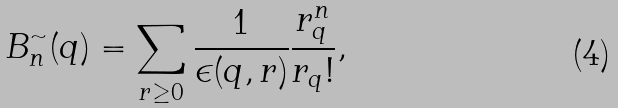<formula> <loc_0><loc_0><loc_500><loc_500>B ^ { \sim } _ { n } ( q ) = \sum _ { r \geq 0 } \frac { 1 } { \epsilon ( q , r ) } \frac { r _ { q } ^ { n } } { r _ { q } ! } ,</formula> 